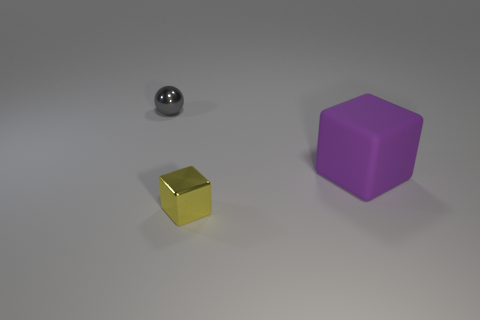The yellow thing that is the same size as the ball is what shape?
Ensure brevity in your answer.  Cube. Is there anything else that has the same color as the small shiny cube?
Offer a terse response. No. What is the size of the thing that is made of the same material as the small block?
Provide a short and direct response. Small. There is a big rubber object; is its shape the same as the tiny object in front of the gray metal object?
Your answer should be very brief. Yes. What size is the gray ball?
Make the answer very short. Small. Is the number of balls to the right of the purple object less than the number of large blue matte blocks?
Give a very brief answer. No. How many yellow metal blocks have the same size as the gray ball?
Your answer should be compact. 1. Do the metal block that is left of the matte object and the thing behind the big purple object have the same color?
Offer a terse response. No. What number of large blocks are left of the gray shiny ball?
Provide a short and direct response. 0. Are there any other yellow objects that have the same shape as the big thing?
Ensure brevity in your answer.  Yes. 